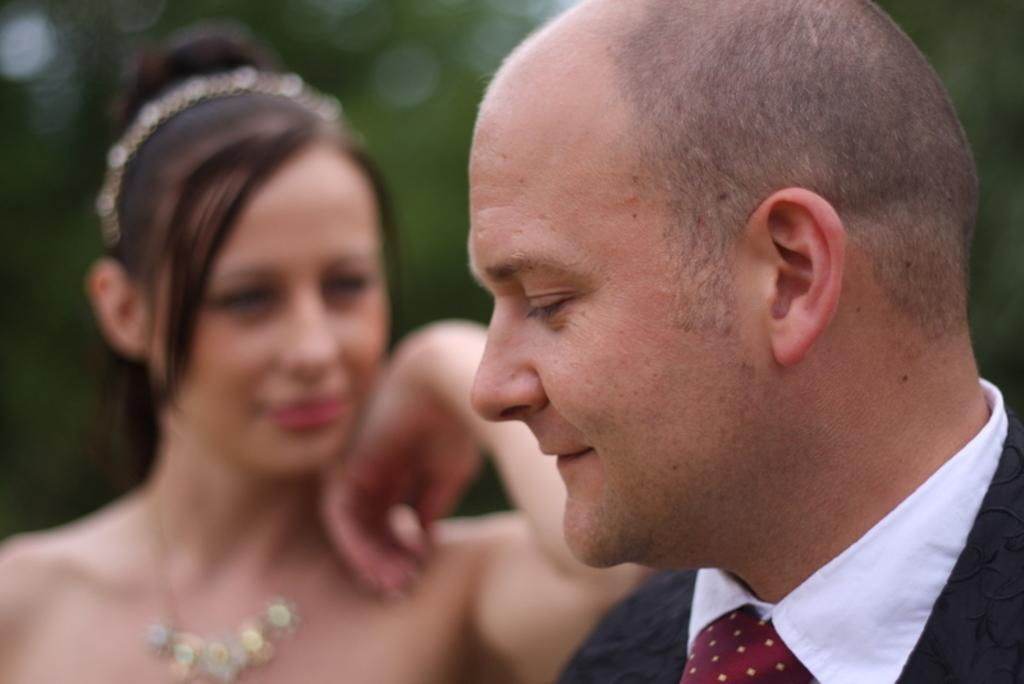Who is present in the image? There is a man and a woman in the image. What is the man doing in the image? The man is smiling in the image. Can you describe the background of the image? The background of the image is blurry. What type of wrench is the man holding in the image? There is no wrench present in the image; the man is simply smiling. Can you see any beans in the image? There are no beans present in the image. 